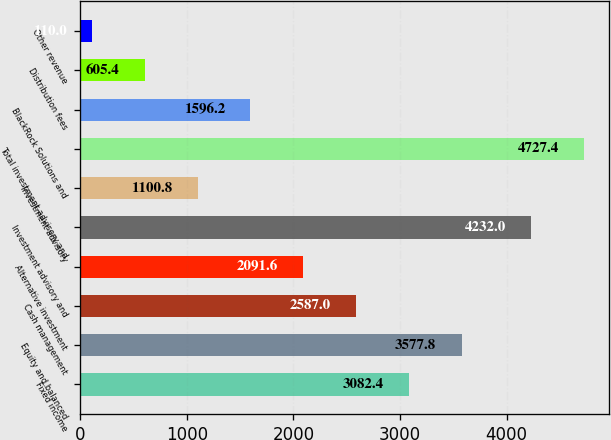Convert chart. <chart><loc_0><loc_0><loc_500><loc_500><bar_chart><fcel>Fixed income<fcel>Equity and balanced<fcel>Cash management<fcel>Alternative investment<fcel>Investment advisory and<fcel>Investment advisory<fcel>Total investment advisory and<fcel>BlackRock Solutions and<fcel>Distribution fees<fcel>Other revenue<nl><fcel>3082.4<fcel>3577.8<fcel>2587<fcel>2091.6<fcel>4232<fcel>1100.8<fcel>4727.4<fcel>1596.2<fcel>605.4<fcel>110<nl></chart> 